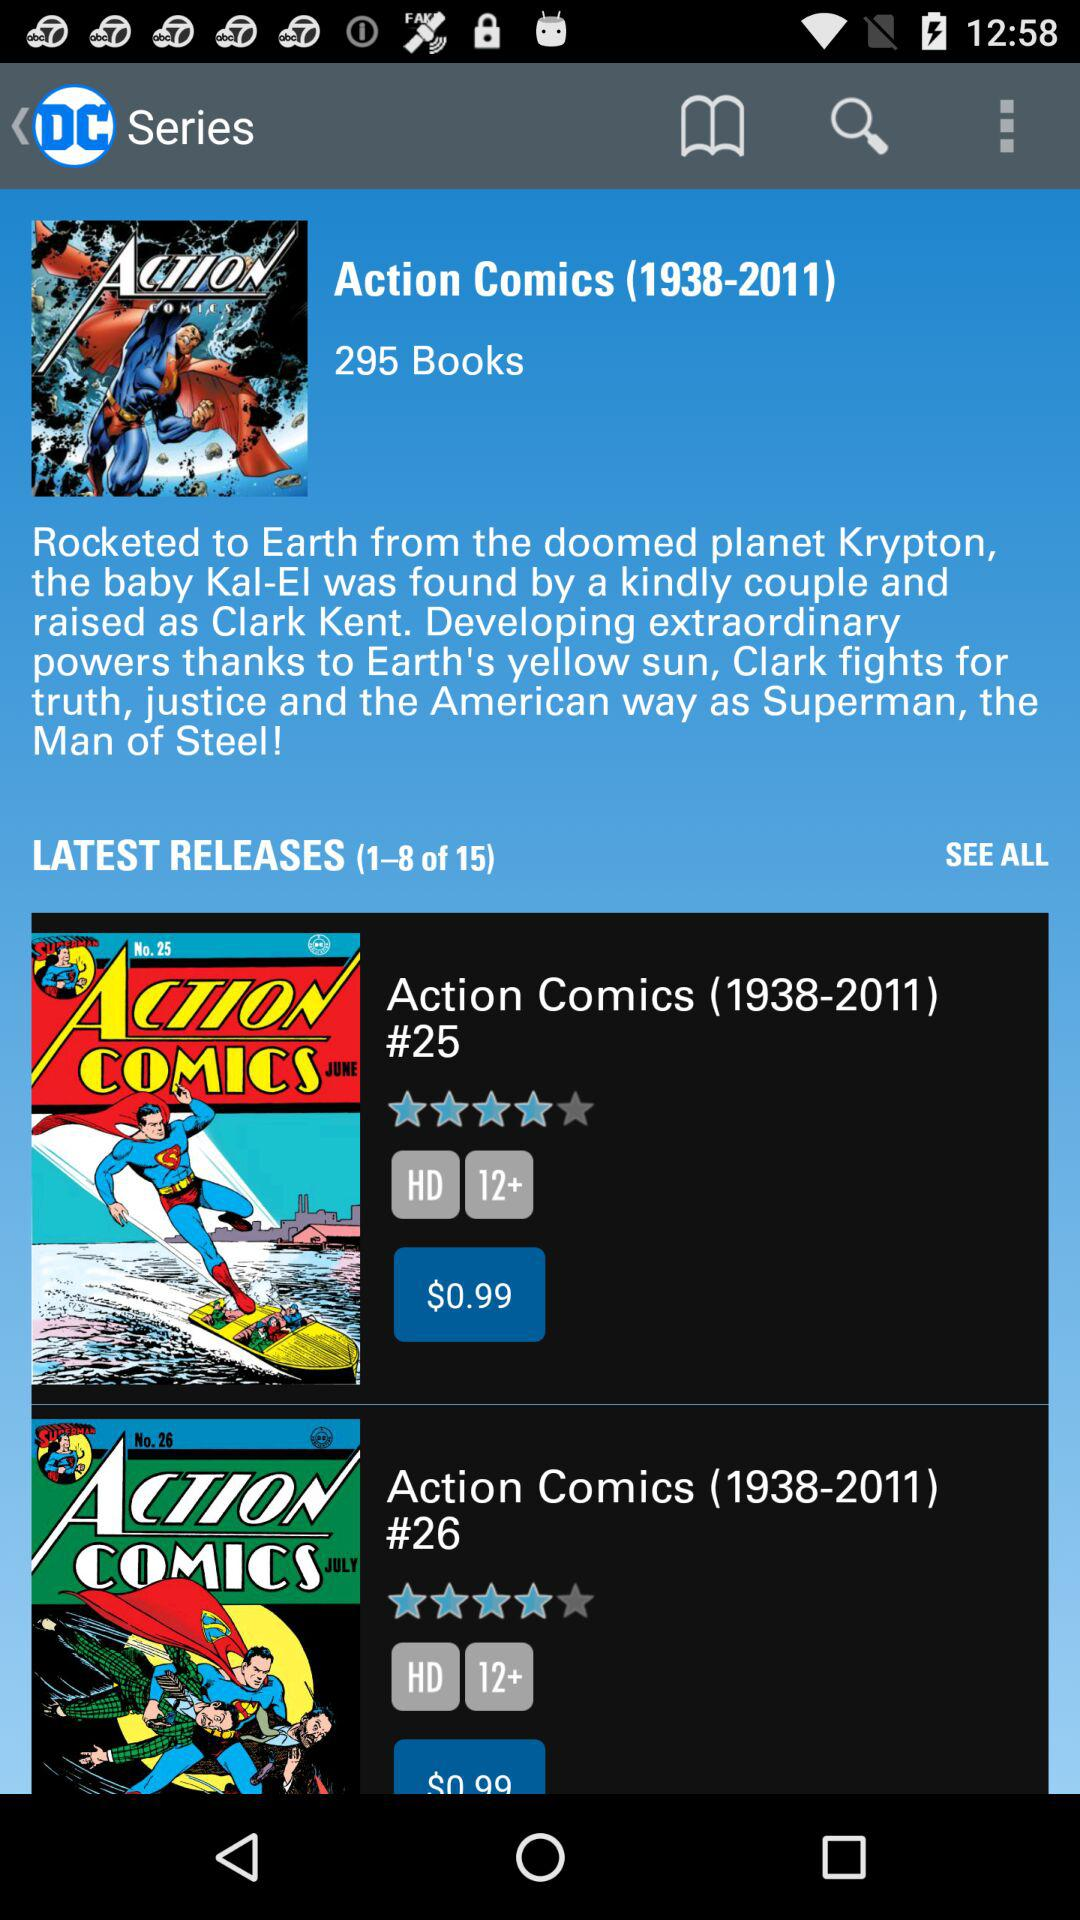What is the total number of books available in "Action Comics"? The total number of books available in "Action Comics" is 295. 